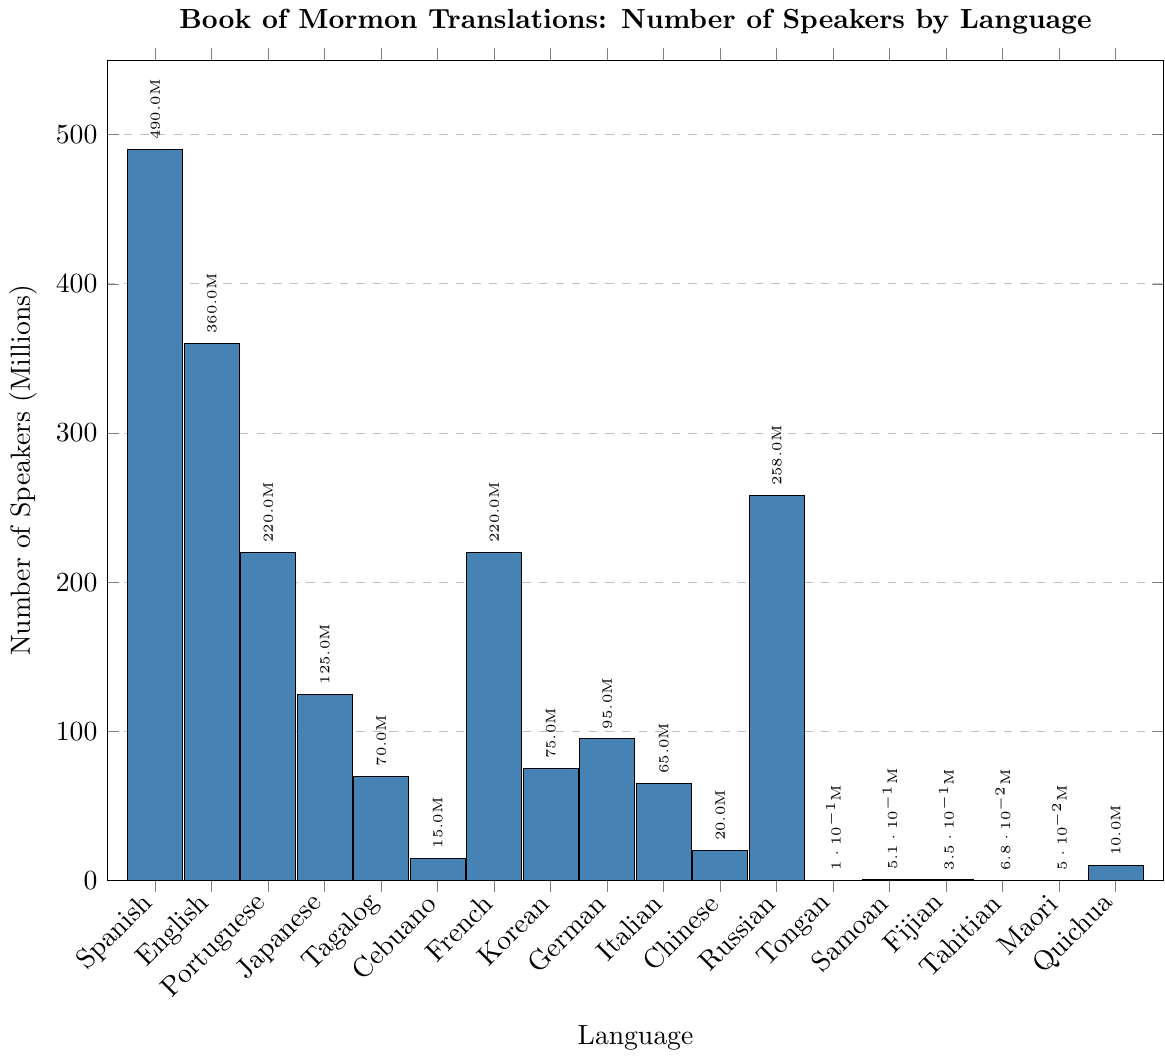Which language has the highest number of speakers for the Book of Mormon translations? By observing the heights of the bars, we can see that the bar for Spanish is the tallest. The legend confirms this with 490 million speakers.
Answer: Spanish How many more speakers are there for the English translation compared to the Portuguese translation? The bar for English corresponds to 360 million speakers, and the bar for Portuguese corresponds to 220 million speakers. Subtracting these values: 360 - 220 = 140 million.
Answer: 140 million What is the total number of speakers for the three languages with the smallest populations: Maori, Tahitian, and Tongan? Observing the figure, the number of speakers for Maori is 0.05 million, for Tahitian is 0.068 million, and for Tongan is 0.1 million. Summing these values: 0.05 + 0.068 + 0.1 = 0.218 million.
Answer: 0.218 million Which of the following two languages has more speakers: Russian or Chinese (Traditional)? From the figure, the bar for Russian is labeled with 258 million speakers, while the bar for Chinese (Traditional) is labeled with 20 million speakers. Since 258 million is greater than 20 million, Russian has more speakers.
Answer: Russian What is the difference in the number of speakers between French and Korean translations? From the chart, the bar for French shows 220 million speakers, and the bar for Korean shows 75 million speakers. Subtracting these values: 220 - 75 = 145 million.
Answer: 145 million What is the average number of speakers for the languages English, Spanish, and Portuguese? English has 360 million speakers, Spanish has 490 million speakers, and Portuguese has 220 million speakers. Summing these values: 360 + 490 + 220 = 1070 million. Dividing by the number of languages, 1070 / 3 ≈ 356.67 million.
Answer: 356.67 million Which languages have fewer than 1 million speakers for the Book of Mormon translations? By examining the shorter bars in the chart, the languages with fewer than 1 million speakers are Tongan with 0.1 million, Samoan with 0.51 million, Fijian with 0.35 million, Tahitian with 0.068 million, and Maori with 0.05 million.
Answer: Tongan, Samoan, Fijian, Tahitian, Maori Which language has a number of speakers closest to the median of all the given languages? To find the median, we first list the number of speakers in ascending order: 0.05, 0.068, 0.1, 0.35, 0.51, 10, 15, 20, 65, 70, 75, 95, 125, 220, 220, 258, 360, 490. With 18 languages, the median will be the average of the 9th and 10th values: (65 + 70) / 2 = 67.5 million. The language with the closest number of speakers to 67.5 million is Tagalog with 70 million.
Answer: Tagalog 